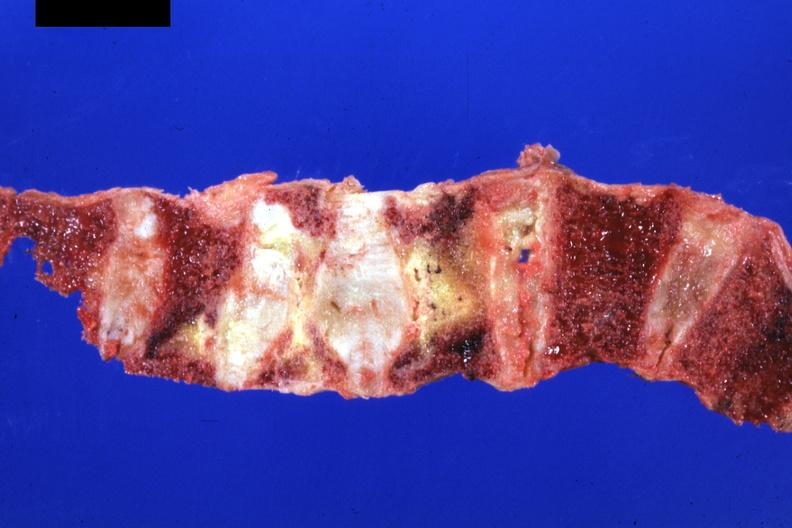does nodule show good representation?
Answer the question using a single word or phrase. No 